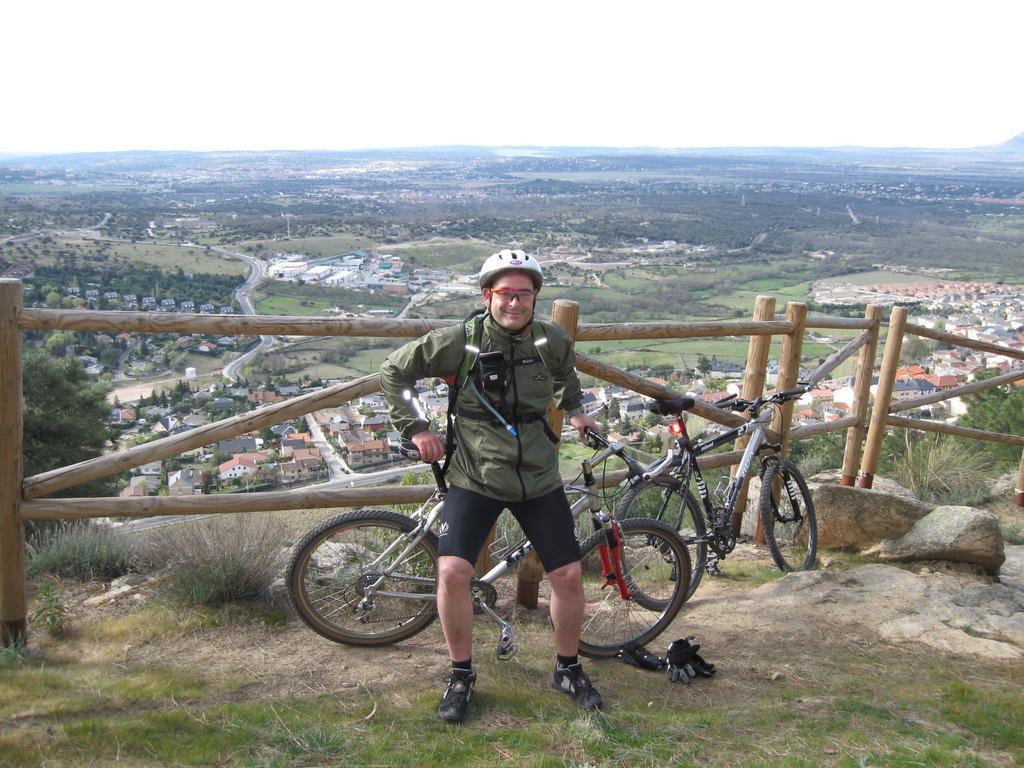Describe this image in one or two sentences. In this image I see a person who is wearing a jacket and shorts and I see that he is also wearing shoes , shades and a helmet and I see that he is smiling and I see 2 cycles and I see the gloves over here and I see the grass, plants and rocks over here. In the background I see the wooden fencing, many houses, trees, road and the sky. 